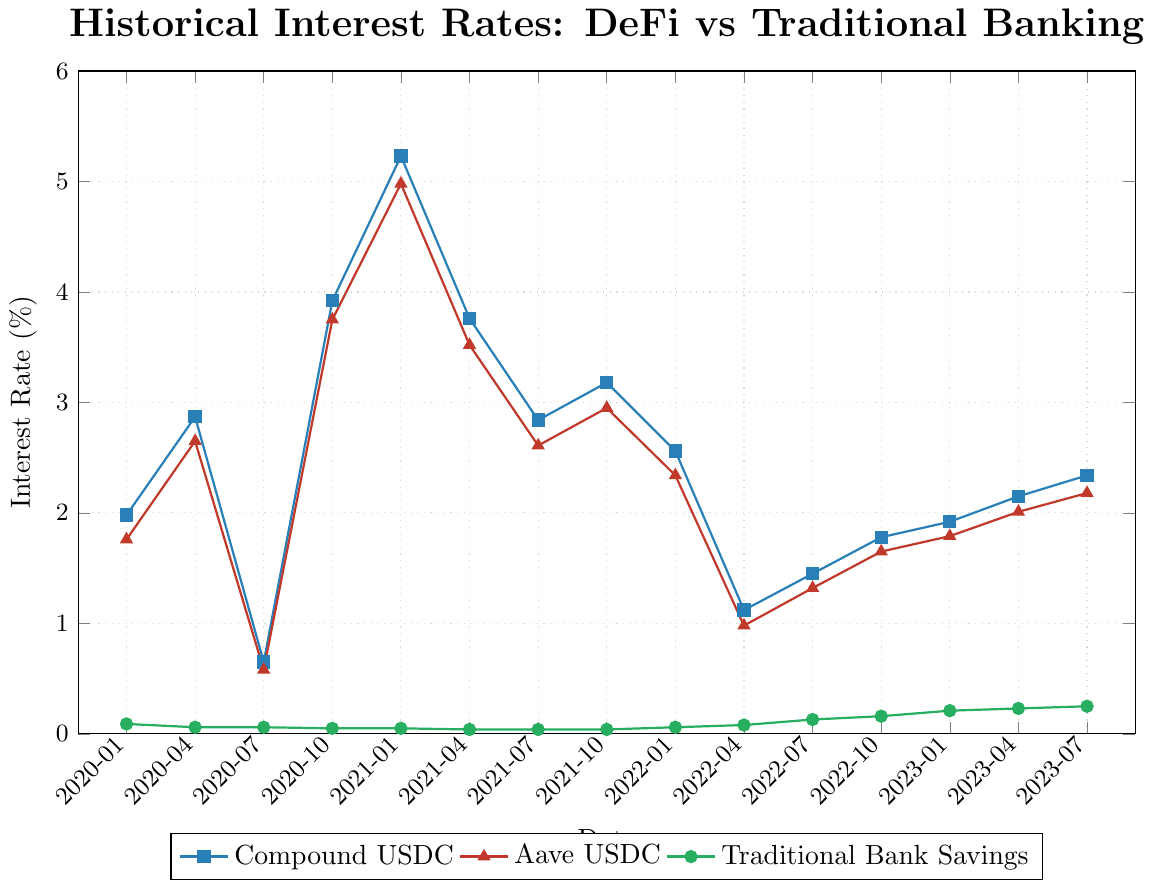Which DeFi platform had the highest interest rate in Q4 2020? Looking at the dates corresponding to Q4 2020 (2020-10-01), we compare the interest rates for Compound USDC and Aave USDC. Compound USDC had a rate of 3.92%, while Aave USDC had a rate of 3.75%.
Answer: Compound USDC What was the average traditional bank savings rate in 2022? The traditional bank savings rates for the quarters in 2022 are 0.06, 0.08, 0.13, and 0.16. Summing these gives 0.43, and dividing by 4 (the number of quarters) gives 0.1075.
Answer: 0.1075% Which period saw the largest decline in Compound USDC rates? Comparing Compound USDC rates across different quarters, the most significant drop appears between 2021-01-01 (5.23%) and 2021-04-01 (3.76%), a difference of 1.47%.
Answer: 2021 Q1 to Q2 How does Aave USDC's rate on 2022-04-01 compare to its rate on 2022-10-01? The rate for Aave USDC on 2022-04-01 was 0.98%, and on 2022-10-01 it was 1.65%. The rate in October was higher.
Answer: Higher in October 2022 What is the combined interest rate for Compound USDC and Aave USDC on 2023-07-01? The interest rate for Compound USDC is 2.34%, and for Aave USDC, it is 2.18%. Adding them gives 4.52%.
Answer: 4.52% During which period were the traditional bank savings rates lower than 0.1%? Looking at the traditional bank savings rates, periods that had rates lower than 0.1% are 2020-01-01 (0.09%), 2020-04-01 (0.06%), 2020-07-01 (0.06%), 2020-10-01 (0.05%), 2021-01-01 (0.05%), 2021-04-01 (0.04%), 2021-07-01 (0.04%), 2021-10-01 (0.04%).
Answer: 2020 to 2021 Q3 Between 2020 and mid-2023, which DeFi platform has a more stable interest rate? By analyzing the plot, Aave USDC shows fewer drastic changes compared to Compound USDC, suggesting more stability.
Answer: Aave USDC What is the interest rate difference between Compound USDC and traditional bank savings on 2020-01-01? The interest rate for Compound USDC on 2020-01-01 is 1.98%, while the traditional bank savings rate is 0.09%. The difference is 1.89%.
Answer: 1.89% In which periods did Compound USDC have an interest rate below 1.5%? The periods when Compound USDC had rates below 1.5% are 2020-07-01 (0.65%), 2022-04-01 (1.12%), and 2022-07-01 (1.45%).
Answer: 2020 Q3 and 2022 Q2 to Q3 